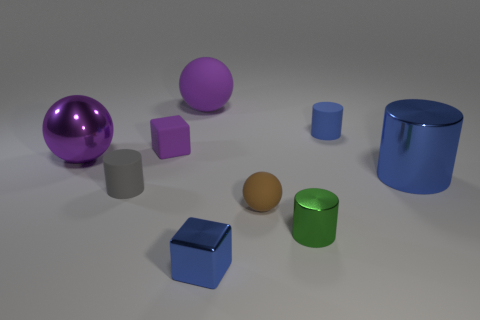Subtract 1 cylinders. How many cylinders are left? 3 Subtract all cubes. How many objects are left? 7 Add 4 tiny gray things. How many tiny gray things exist? 5 Subtract 0 yellow spheres. How many objects are left? 9 Subtract all cubes. Subtract all green metallic balls. How many objects are left? 7 Add 7 metal spheres. How many metal spheres are left? 8 